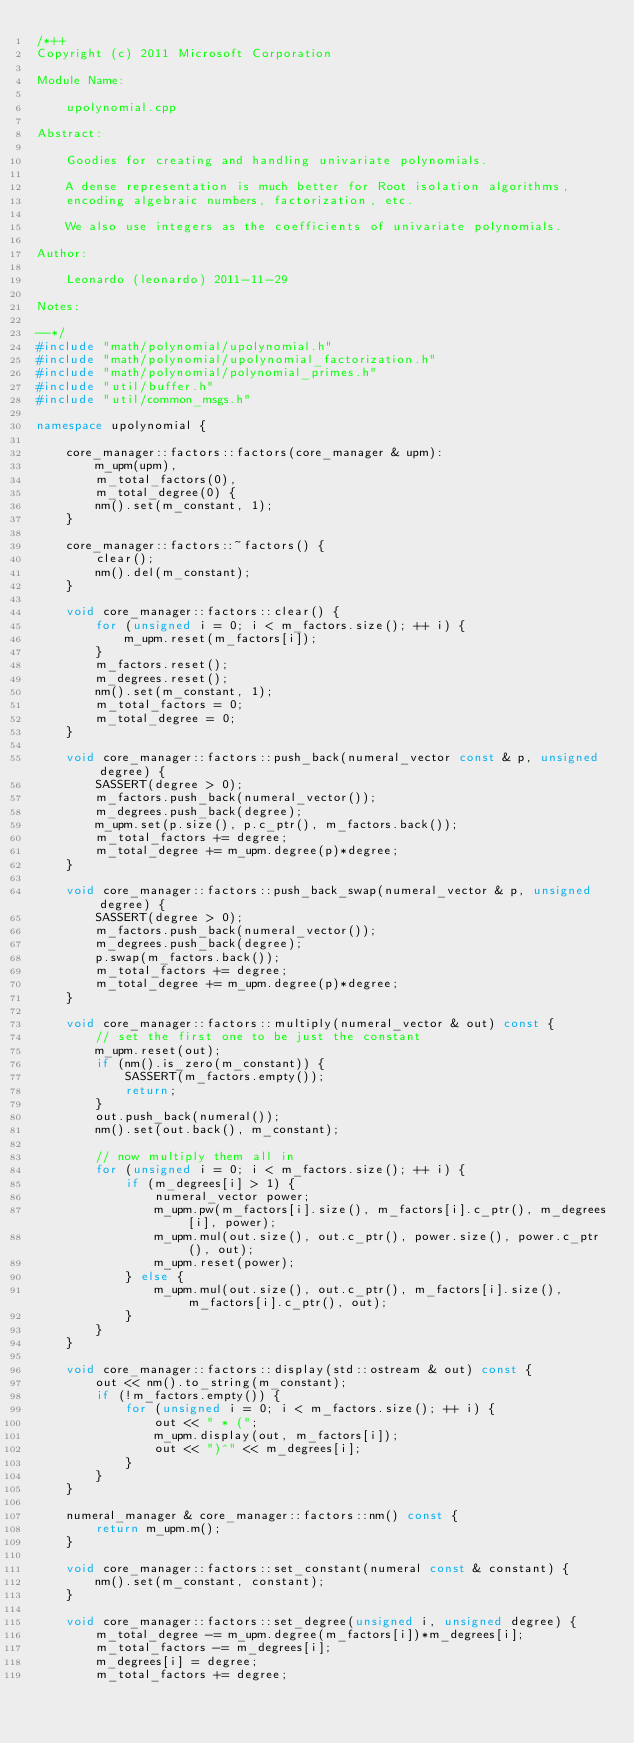Convert code to text. <code><loc_0><loc_0><loc_500><loc_500><_C++_>/*++
Copyright (c) 2011 Microsoft Corporation

Module Name:

    upolynomial.cpp

Abstract:

    Goodies for creating and handling univariate polynomials.

    A dense representation is much better for Root isolation algorithms,
    encoding algebraic numbers, factorization, etc.

    We also use integers as the coefficients of univariate polynomials.

Author:

    Leonardo (leonardo) 2011-11-29

Notes:

--*/
#include "math/polynomial/upolynomial.h"
#include "math/polynomial/upolynomial_factorization.h"
#include "math/polynomial/polynomial_primes.h"
#include "util/buffer.h"
#include "util/common_msgs.h"

namespace upolynomial {

    core_manager::factors::factors(core_manager & upm):
        m_upm(upm),
        m_total_factors(0),
        m_total_degree(0) {
        nm().set(m_constant, 1);
    }

    core_manager::factors::~factors() {
        clear();
        nm().del(m_constant);
    }

    void core_manager::factors::clear() {
        for (unsigned i = 0; i < m_factors.size(); ++ i) {
            m_upm.reset(m_factors[i]);
        }
        m_factors.reset();
        m_degrees.reset();
        nm().set(m_constant, 1);
        m_total_factors = 0;
        m_total_degree = 0;
    }

    void core_manager::factors::push_back(numeral_vector const & p, unsigned degree) {
        SASSERT(degree > 0);
        m_factors.push_back(numeral_vector());
        m_degrees.push_back(degree);
        m_upm.set(p.size(), p.c_ptr(), m_factors.back());
        m_total_factors += degree;
        m_total_degree += m_upm.degree(p)*degree;
    }

    void core_manager::factors::push_back_swap(numeral_vector & p, unsigned degree) {
        SASSERT(degree > 0);
        m_factors.push_back(numeral_vector());
        m_degrees.push_back(degree);
        p.swap(m_factors.back());
        m_total_factors += degree;
        m_total_degree += m_upm.degree(p)*degree;
    }

    void core_manager::factors::multiply(numeral_vector & out) const {
        // set the first one to be just the constant
        m_upm.reset(out);
        if (nm().is_zero(m_constant)) {
            SASSERT(m_factors.empty());
            return;
        }
        out.push_back(numeral());
        nm().set(out.back(), m_constant);

        // now multiply them all in
        for (unsigned i = 0; i < m_factors.size(); ++ i) {
            if (m_degrees[i] > 1) {
                numeral_vector power;
                m_upm.pw(m_factors[i].size(), m_factors[i].c_ptr(), m_degrees[i], power);
                m_upm.mul(out.size(), out.c_ptr(), power.size(), power.c_ptr(), out);
                m_upm.reset(power);
            } else {
                m_upm.mul(out.size(), out.c_ptr(), m_factors[i].size(), m_factors[i].c_ptr(), out);
            }
        }
    }

    void core_manager::factors::display(std::ostream & out) const {
        out << nm().to_string(m_constant);
        if (!m_factors.empty()) {
            for (unsigned i = 0; i < m_factors.size(); ++ i) {
                out << " * (";
                m_upm.display(out, m_factors[i]);
                out << ")^" << m_degrees[i];
            }
        }
    }

    numeral_manager & core_manager::factors::nm() const {
        return m_upm.m();
    }

    void core_manager::factors::set_constant(numeral const & constant) {
        nm().set(m_constant, constant);
    }

    void core_manager::factors::set_degree(unsigned i, unsigned degree) {
        m_total_degree -= m_upm.degree(m_factors[i])*m_degrees[i];
        m_total_factors -= m_degrees[i];
        m_degrees[i] = degree;
        m_total_factors += degree;</code> 